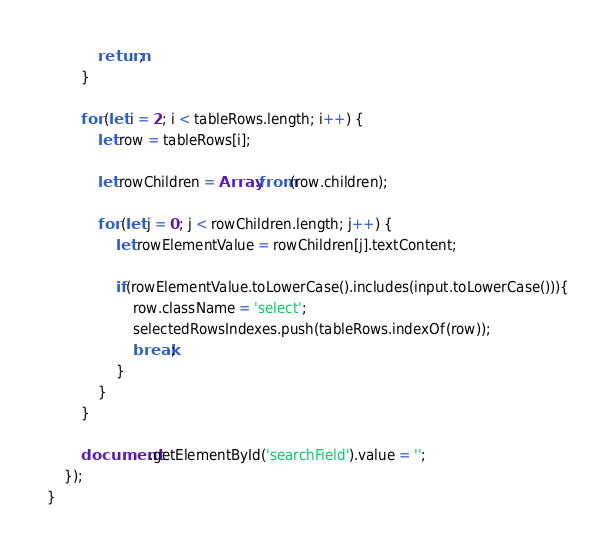<code> <loc_0><loc_0><loc_500><loc_500><_JavaScript_>            return;
        }

        for (let i = 2; i < tableRows.length; i++) {
            let row = tableRows[i];

            let rowChildren = Array.from(row.children);

            for (let j = 0; j < rowChildren.length; j++) {
                let rowElementValue = rowChildren[j].textContent;

                if(rowElementValue.toLowerCase().includes(input.toLowerCase())){
                    row.className = 'select';
                    selectedRowsIndexes.push(tableRows.indexOf(row));
                    break;
                }
            }
        }

        document.getElementById('searchField').value = '';
    });
}</code> 